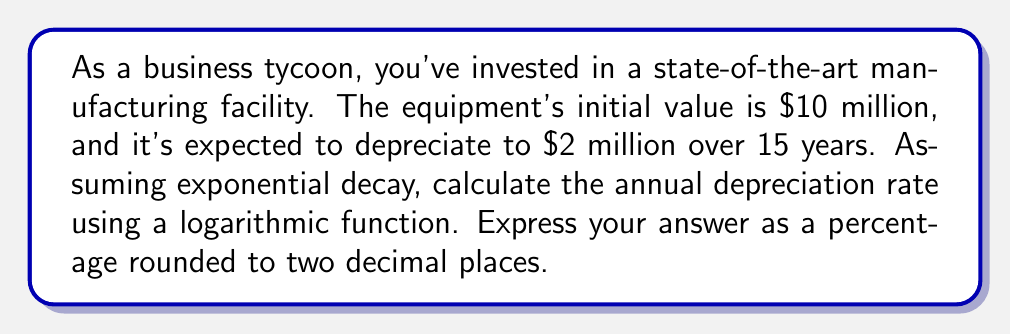Can you solve this math problem? Let's approach this step-by-step using the exponential decay formula and logarithms:

1) The exponential decay formula is:
   $A = P(1-r)^t$
   where A is the final value, P is the initial value, r is the annual depreciation rate, and t is the time in years.

2) We know:
   P = $10 million
   A = $2 million
   t = 15 years

3) Substituting these values:
   $2 = 10(1-r)^{15}$

4) Dividing both sides by 10:
   $0.2 = (1-r)^{15}$

5) Taking the natural logarithm of both sides:
   $\ln(0.2) = 15\ln(1-r)$

6) Dividing both sides by 15:
   $\frac{\ln(0.2)}{15} = \ln(1-r)$

7) Taking the exponential of both sides:
   $e^{\frac{\ln(0.2)}{15}} = 1-r$

8) Subtracting from 1:
   $r = 1 - e^{\frac{\ln(0.2)}{15}}$

9) Calculating:
   $r = 1 - e^{-0.1076} \approx 0.1020$

10) Converting to a percentage:
    0.1020 * 100 = 10.20%
Answer: 10.20% 